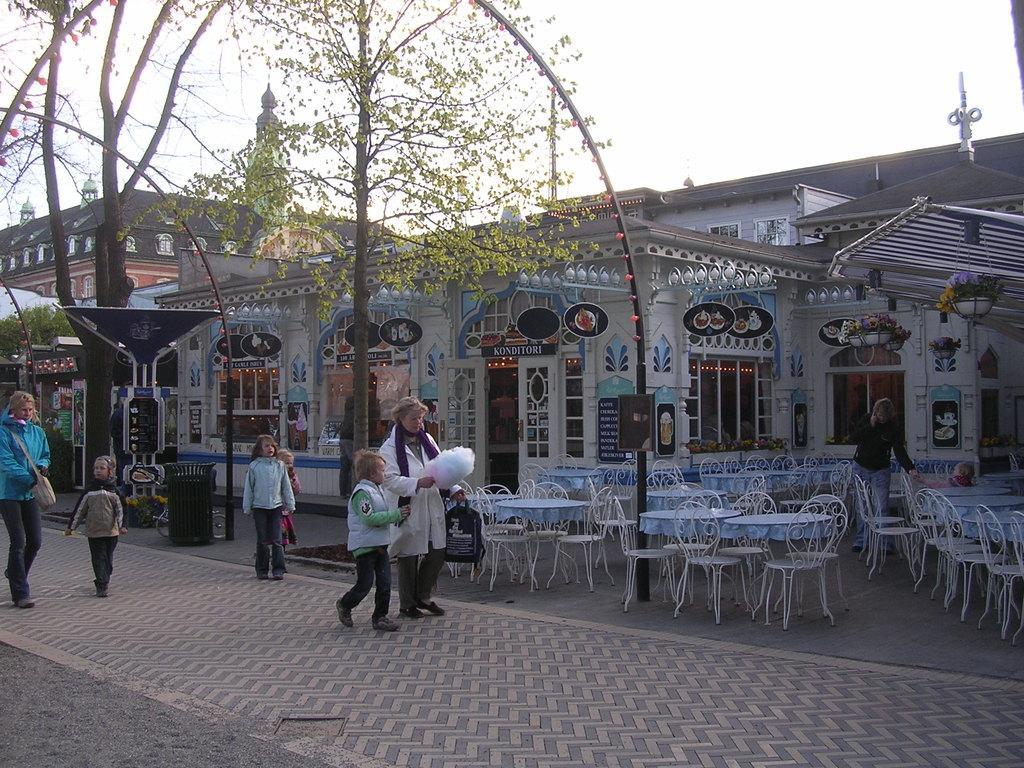Could you give a brief overview of what you see in this image? In the image we can see few persons were walking on the road and holding back pack. In the background there is a sky,clouds,trees,building,wall,tables,chairs,light etc. 